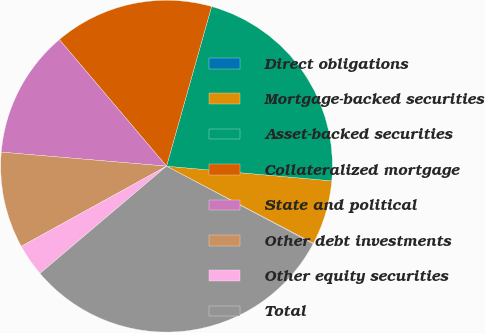Convert chart. <chart><loc_0><loc_0><loc_500><loc_500><pie_chart><fcel>Direct obligations<fcel>Mortgage-backed securities<fcel>Asset-backed securities<fcel>Collateralized mortgage<fcel>State and political<fcel>Other debt investments<fcel>Other equity securities<fcel>Total<nl><fcel>0.07%<fcel>6.27%<fcel>22.04%<fcel>15.56%<fcel>12.47%<fcel>9.37%<fcel>3.17%<fcel>31.06%<nl></chart> 